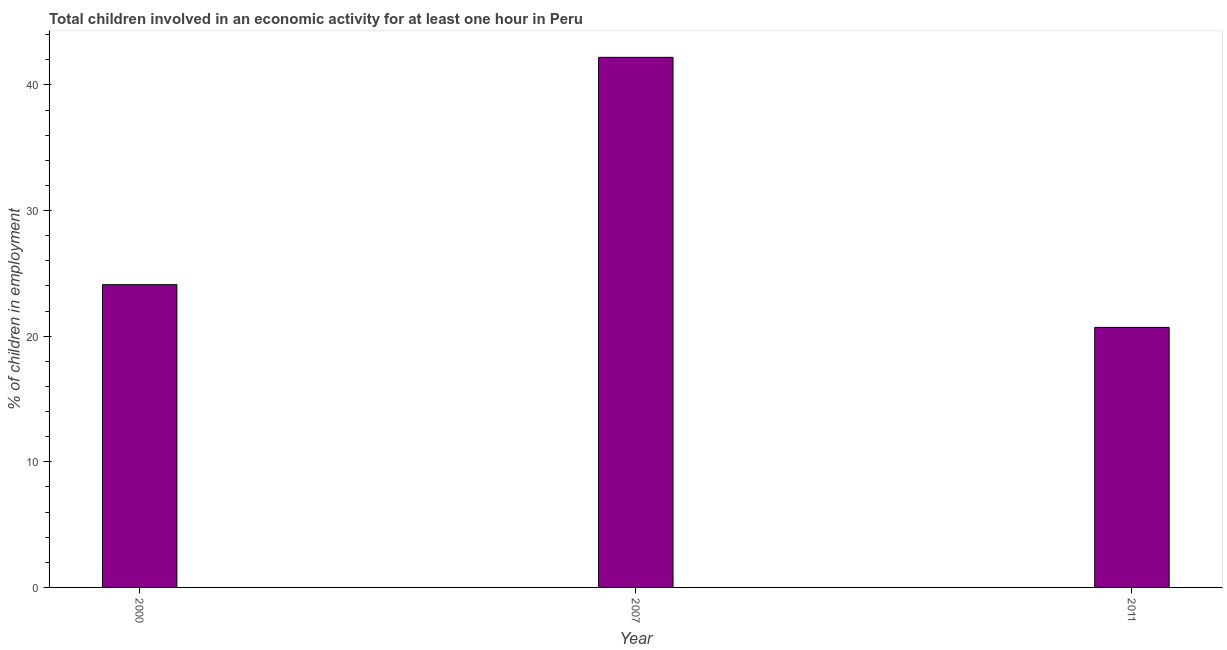Does the graph contain grids?
Your response must be concise. No. What is the title of the graph?
Your answer should be very brief. Total children involved in an economic activity for at least one hour in Peru. What is the label or title of the Y-axis?
Give a very brief answer. % of children in employment. What is the percentage of children in employment in 2007?
Keep it short and to the point. 42.2. Across all years, what is the maximum percentage of children in employment?
Offer a very short reply. 42.2. Across all years, what is the minimum percentage of children in employment?
Provide a short and direct response. 20.7. In which year was the percentage of children in employment minimum?
Offer a terse response. 2011. What is the sum of the percentage of children in employment?
Make the answer very short. 87. What is the median percentage of children in employment?
Offer a terse response. 24.1. In how many years, is the percentage of children in employment greater than 32 %?
Your answer should be very brief. 1. What is the ratio of the percentage of children in employment in 2000 to that in 2007?
Your response must be concise. 0.57. Is the sum of the percentage of children in employment in 2007 and 2011 greater than the maximum percentage of children in employment across all years?
Keep it short and to the point. Yes. What is the difference between the highest and the lowest percentage of children in employment?
Make the answer very short. 21.5. How many years are there in the graph?
Offer a terse response. 3. Are the values on the major ticks of Y-axis written in scientific E-notation?
Offer a terse response. No. What is the % of children in employment of 2000?
Ensure brevity in your answer.  24.1. What is the % of children in employment of 2007?
Offer a terse response. 42.2. What is the % of children in employment of 2011?
Ensure brevity in your answer.  20.7. What is the difference between the % of children in employment in 2000 and 2007?
Your answer should be compact. -18.1. What is the difference between the % of children in employment in 2000 and 2011?
Ensure brevity in your answer.  3.4. What is the ratio of the % of children in employment in 2000 to that in 2007?
Provide a succinct answer. 0.57. What is the ratio of the % of children in employment in 2000 to that in 2011?
Your answer should be very brief. 1.16. What is the ratio of the % of children in employment in 2007 to that in 2011?
Ensure brevity in your answer.  2.04. 